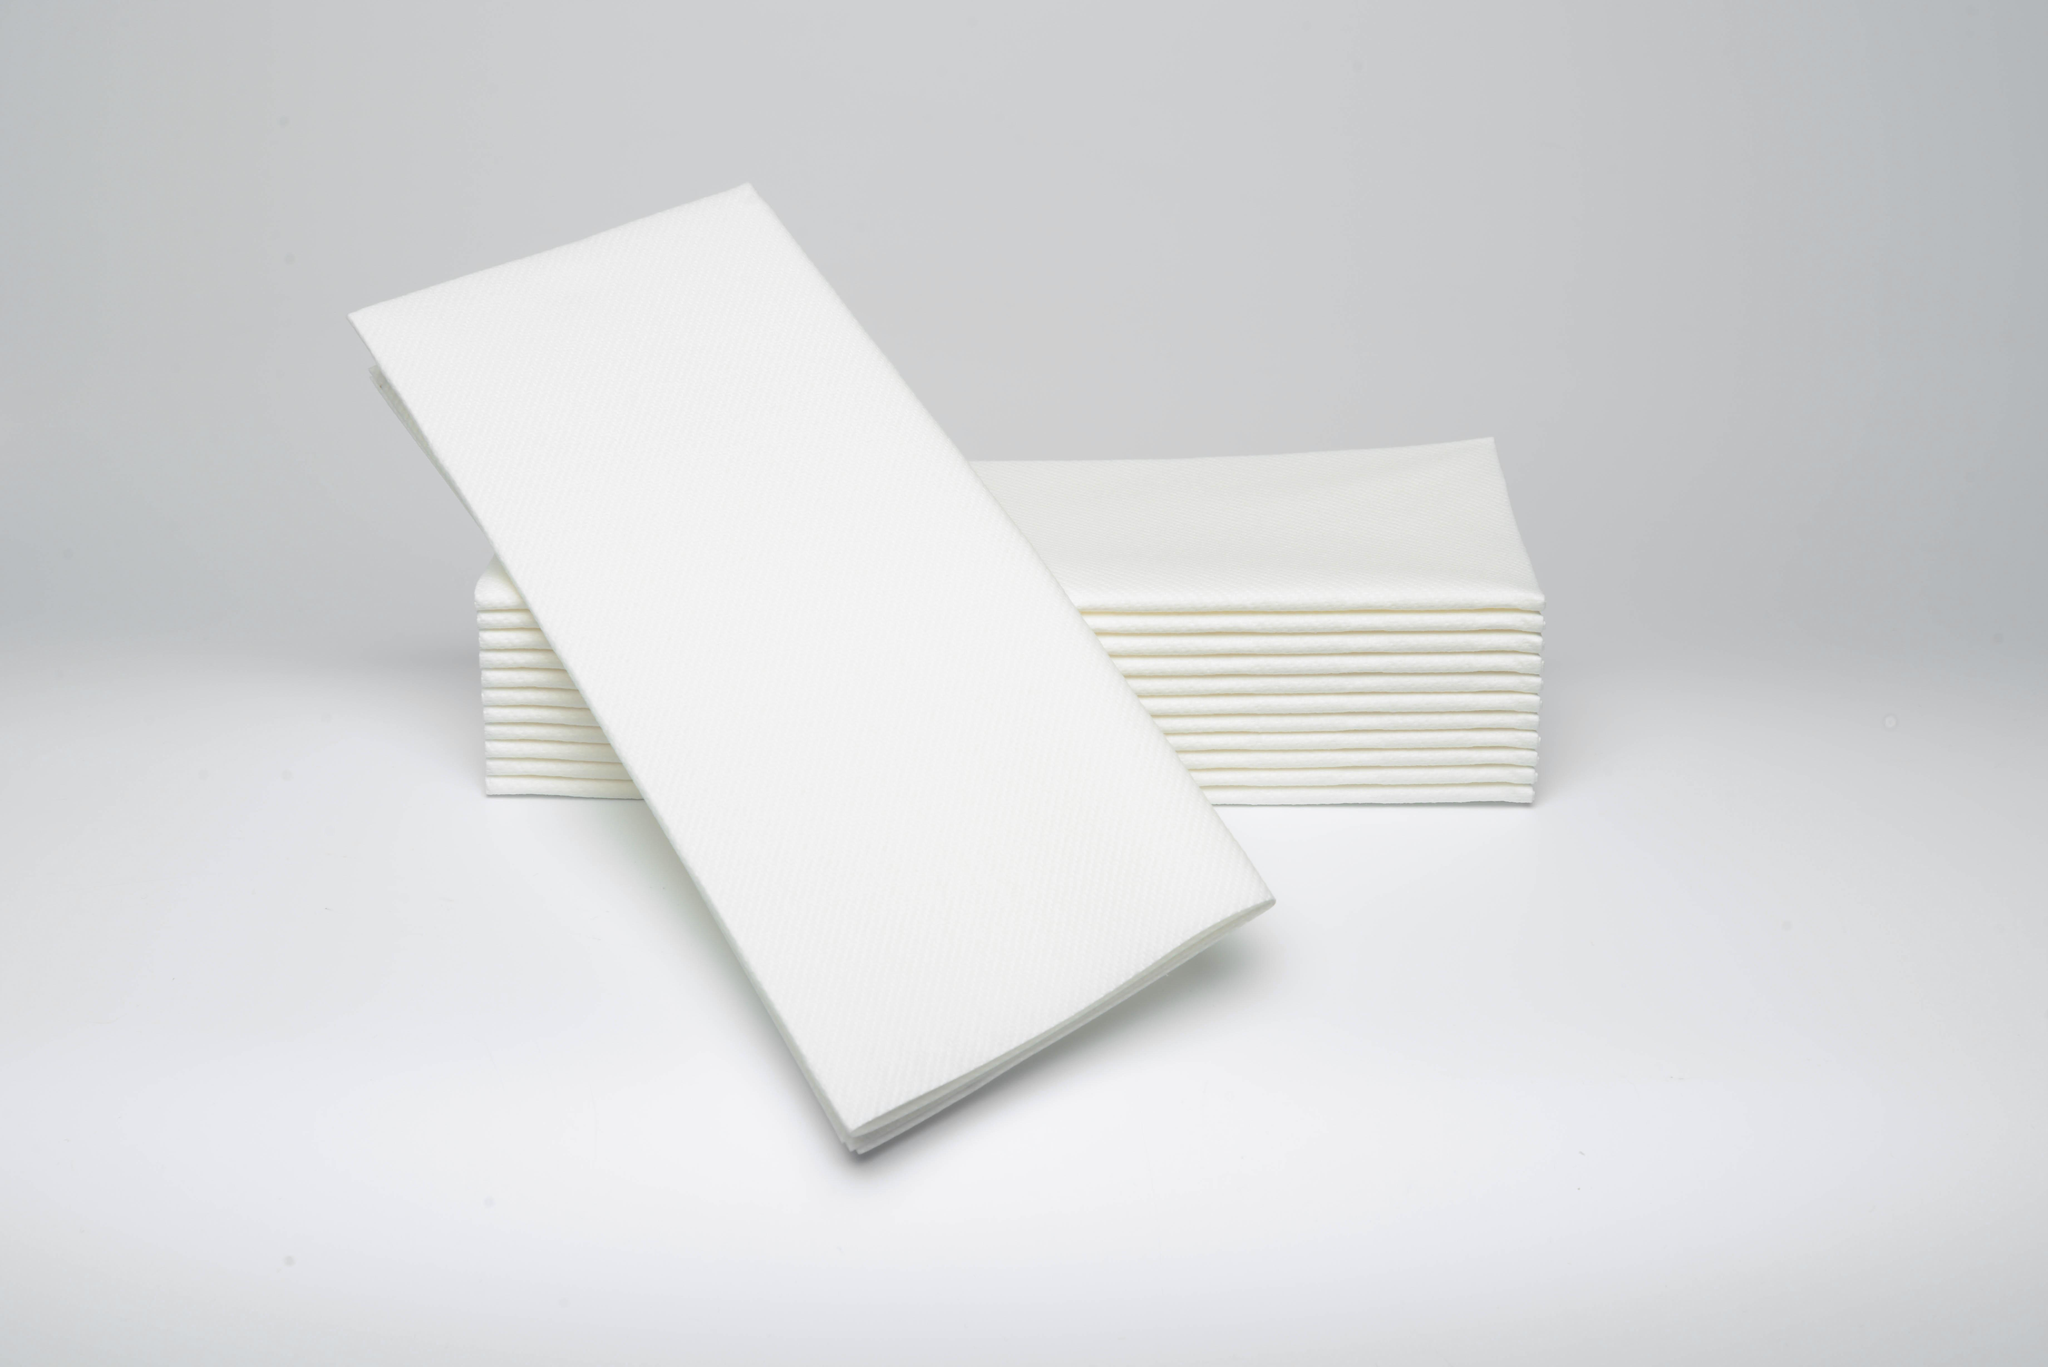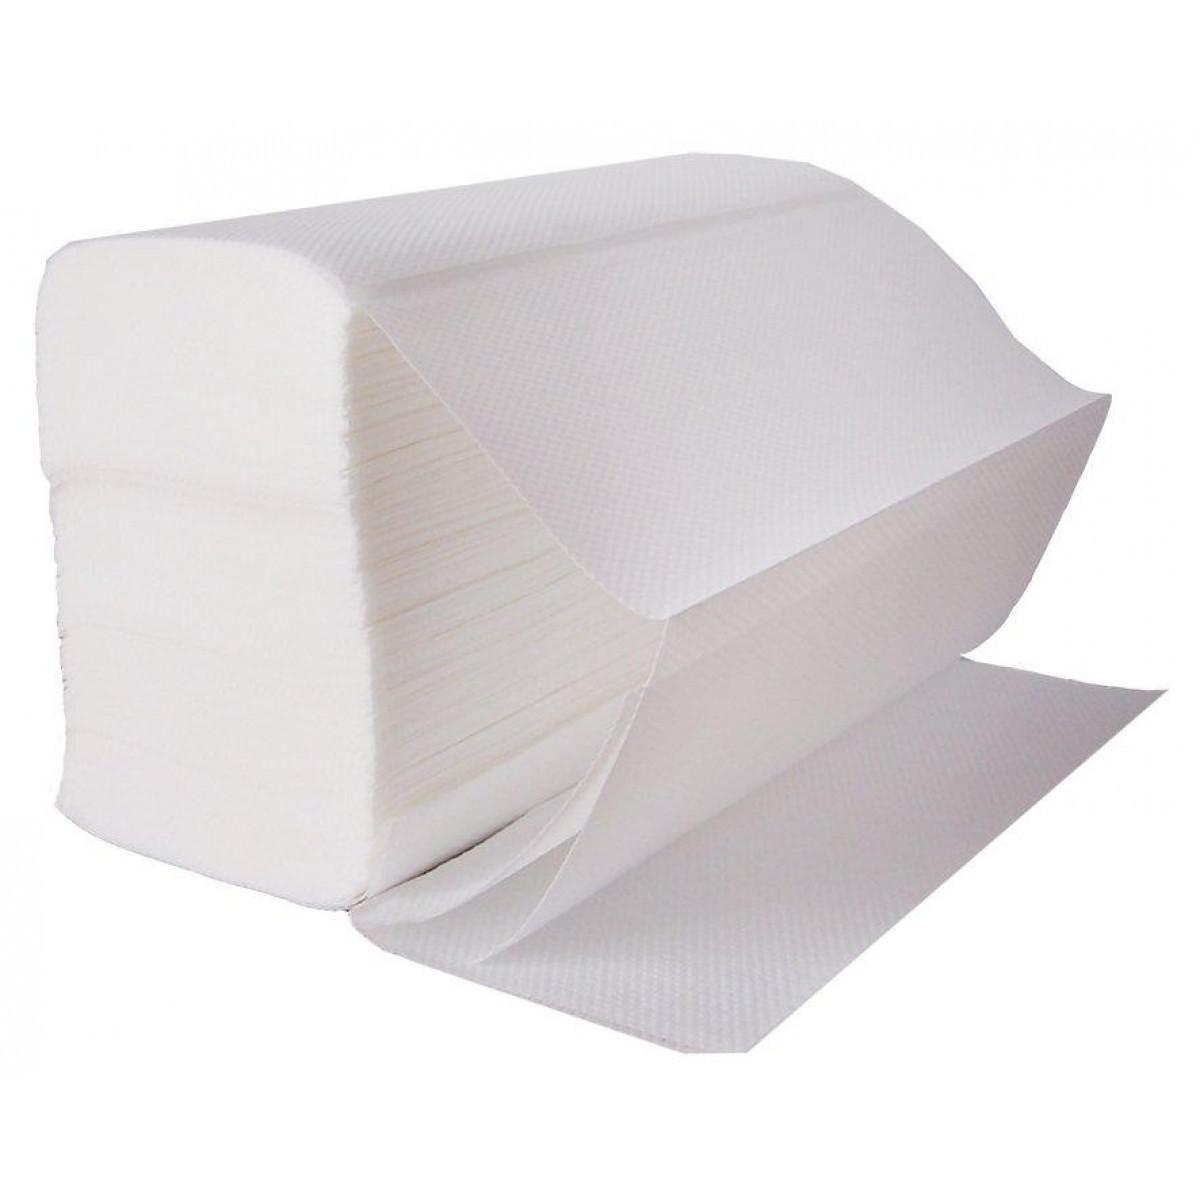The first image is the image on the left, the second image is the image on the right. Considering the images on both sides, is "An image shows one stack of solid-white folded paper towels displayed at an angle, with the top sheet opening like an accordion and draped over the front of the stack." valid? Answer yes or no. Yes. 